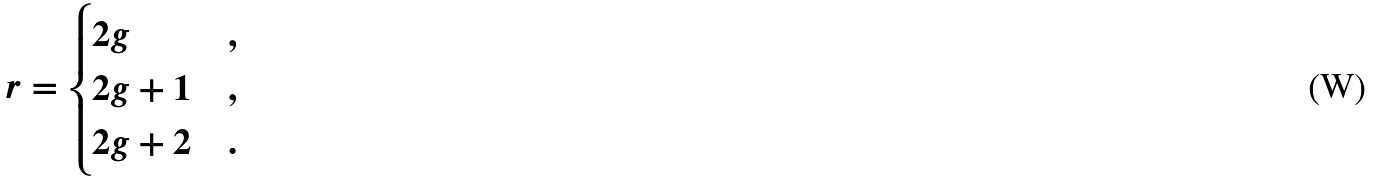Convert formula to latex. <formula><loc_0><loc_0><loc_500><loc_500>r = \begin{cases} 2 g & , \\ 2 g + 1 & , \\ 2 g + 2 & . \end{cases}</formula> 